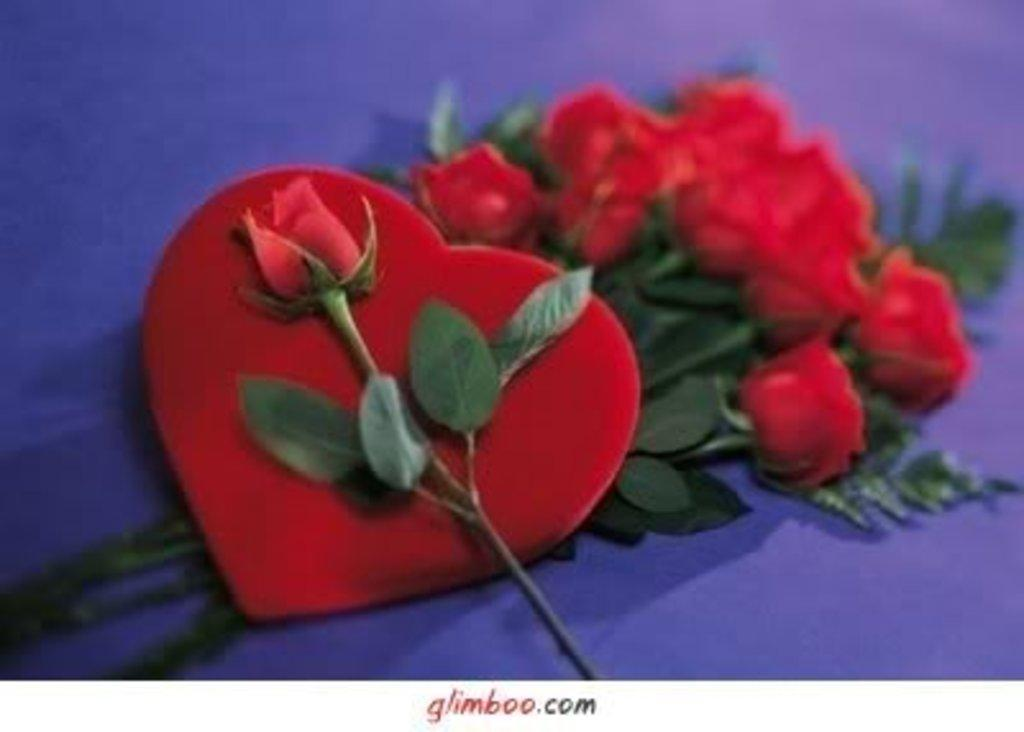What type of flowers are in the image? There are red roses in the image. What other plant elements can be seen in the image? There are leaves in the image. What shape is the heart-shaped thing in the image? The heart-shaped thing in the image is, as described, heart-shaped. What color is the surface in the image? The surface in the image is purple. What type of business is being conducted in the image? There is no indication of a business in the image; it features red roses, leaves, a heart-shaped thing, and a purple surface. Can you see any ghosts in the image? There are no ghosts present in the image. 